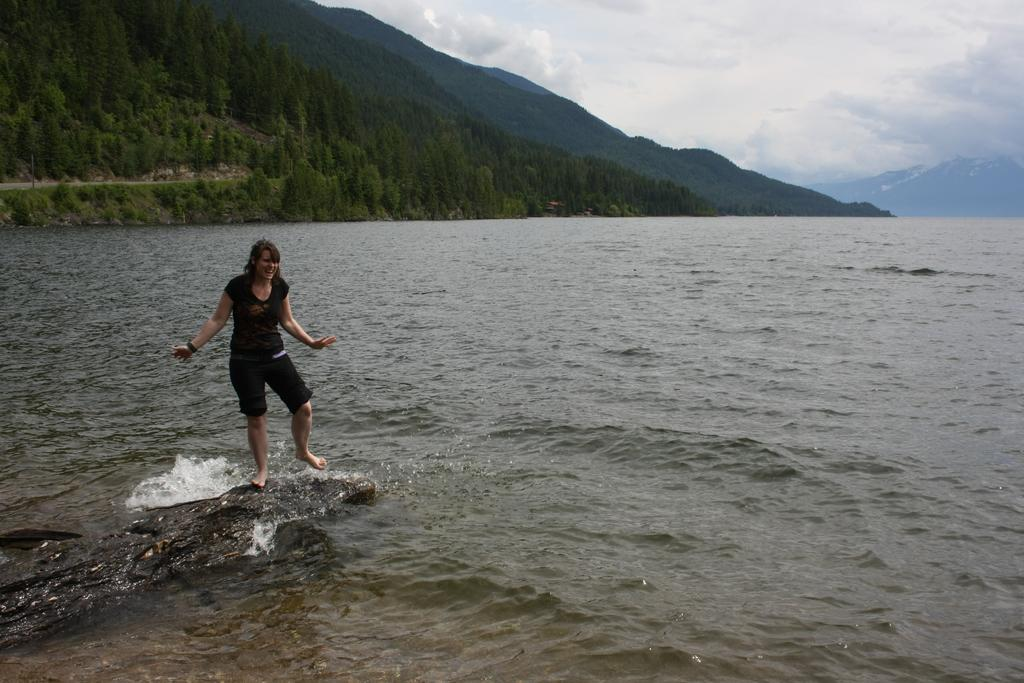Who is present in the image? There is a woman in the image. What is the woman standing on? The woman is standing on a stone. What can be seen in the background of the image? There is water and trees visible in the image. How would you describe the sky in the image? The sky is blue and cloudy. What is the woman wearing in the image? The woman is wearing a black dress. What type of cloth is being used to cover the cellar in the image? There is no cellar or cloth present in the image. Can you hear the woman laughing in the image? The image is silent, so we cannot hear the woman laughing. 